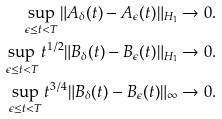<formula> <loc_0><loc_0><loc_500><loc_500>\sup _ { \epsilon \leq t < T } \| A _ { \delta } ( t ) - A _ { \epsilon } ( t ) \| _ { H _ { 1 } } & \rightarrow 0 . \\ \sup _ { \epsilon \leq t < T } t ^ { 1 / 2 } \| B _ { \delta } ( t ) - B _ { \epsilon } ( t ) \| _ { H _ { 1 } } & \rightarrow 0 . \\ \sup _ { \epsilon \leq t < T } t ^ { 3 / 4 } \| B _ { \delta } ( t ) - B _ { \epsilon } ( t ) \| _ { \infty } & \rightarrow 0 .</formula> 